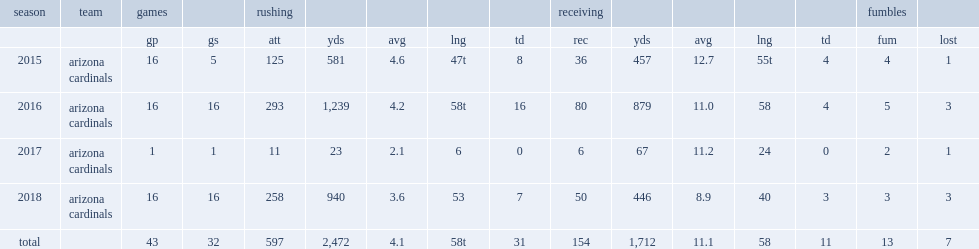How many rushing yards did david johnson get in 2015? 581.0. 